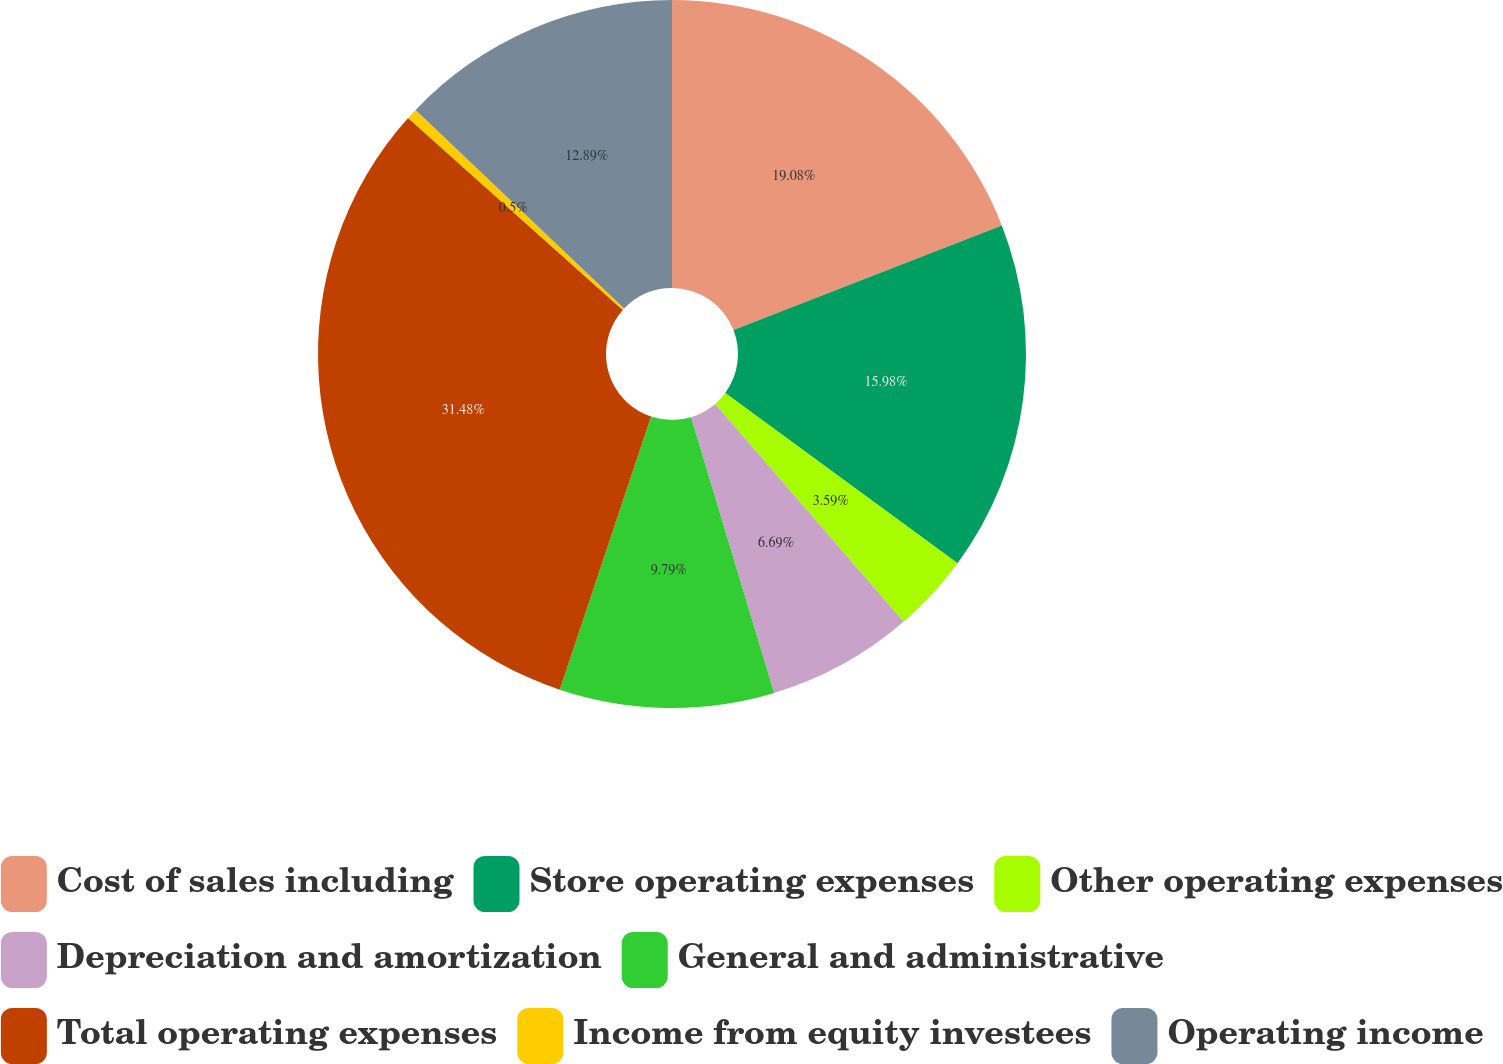Convert chart to OTSL. <chart><loc_0><loc_0><loc_500><loc_500><pie_chart><fcel>Cost of sales including<fcel>Store operating expenses<fcel>Other operating expenses<fcel>Depreciation and amortization<fcel>General and administrative<fcel>Total operating expenses<fcel>Income from equity investees<fcel>Operating income<nl><fcel>19.08%<fcel>15.98%<fcel>3.59%<fcel>6.69%<fcel>9.79%<fcel>31.47%<fcel>0.5%<fcel>12.89%<nl></chart> 